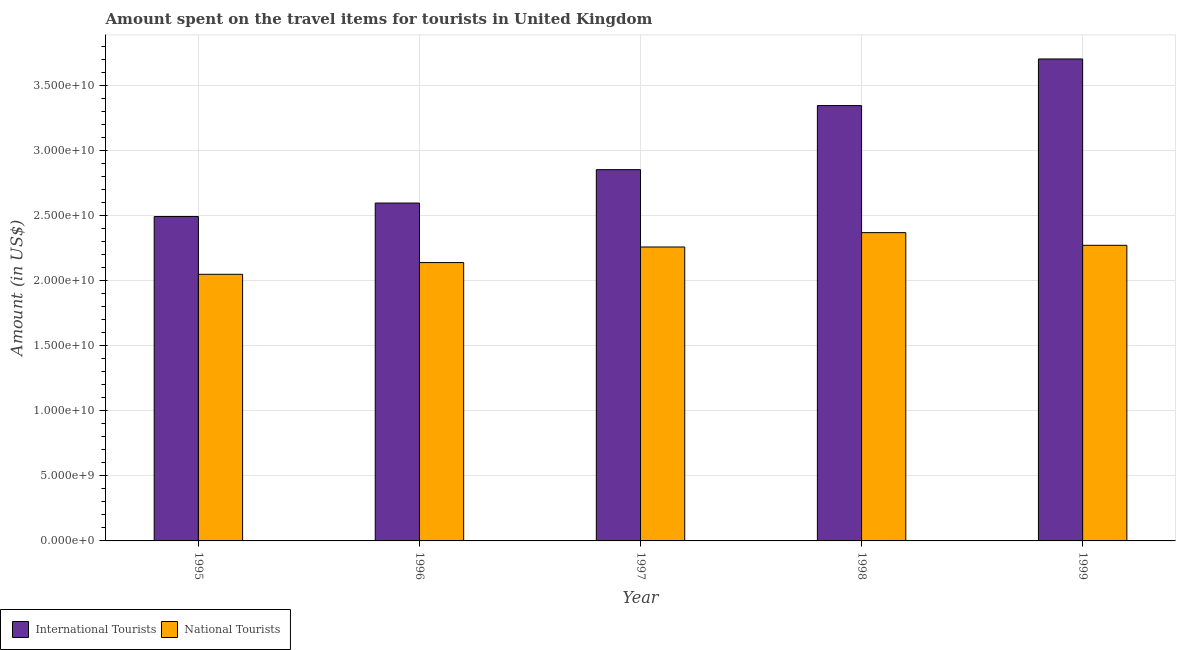How many different coloured bars are there?
Provide a succinct answer. 2. How many bars are there on the 3rd tick from the right?
Your answer should be very brief. 2. What is the label of the 5th group of bars from the left?
Your answer should be compact. 1999. In how many cases, is the number of bars for a given year not equal to the number of legend labels?
Your answer should be compact. 0. What is the amount spent on travel items of international tourists in 1999?
Your answer should be compact. 3.70e+1. Across all years, what is the maximum amount spent on travel items of international tourists?
Provide a succinct answer. 3.70e+1. Across all years, what is the minimum amount spent on travel items of national tourists?
Provide a succinct answer. 2.05e+1. In which year was the amount spent on travel items of national tourists minimum?
Provide a short and direct response. 1995. What is the total amount spent on travel items of national tourists in the graph?
Provide a succinct answer. 1.11e+11. What is the difference between the amount spent on travel items of international tourists in 1996 and that in 1998?
Give a very brief answer. -7.49e+09. What is the difference between the amount spent on travel items of international tourists in 1996 and the amount spent on travel items of national tourists in 1999?
Ensure brevity in your answer.  -1.11e+1. What is the average amount spent on travel items of international tourists per year?
Your answer should be very brief. 3.00e+1. What is the ratio of the amount spent on travel items of national tourists in 1995 to that in 1997?
Provide a succinct answer. 0.91. What is the difference between the highest and the second highest amount spent on travel items of national tourists?
Your response must be concise. 9.73e+08. What is the difference between the highest and the lowest amount spent on travel items of national tourists?
Provide a succinct answer. 3.20e+09. What does the 2nd bar from the left in 1995 represents?
Your response must be concise. National Tourists. What does the 1st bar from the right in 1996 represents?
Offer a terse response. National Tourists. How many years are there in the graph?
Provide a succinct answer. 5. Does the graph contain grids?
Your answer should be compact. Yes. How many legend labels are there?
Offer a very short reply. 2. What is the title of the graph?
Give a very brief answer. Amount spent on the travel items for tourists in United Kingdom. What is the label or title of the Y-axis?
Your response must be concise. Amount (in US$). What is the Amount (in US$) of International Tourists in 1995?
Make the answer very short. 2.49e+1. What is the Amount (in US$) of National Tourists in 1995?
Your answer should be very brief. 2.05e+1. What is the Amount (in US$) in International Tourists in 1996?
Make the answer very short. 2.60e+1. What is the Amount (in US$) in National Tourists in 1996?
Ensure brevity in your answer.  2.14e+1. What is the Amount (in US$) in International Tourists in 1997?
Your answer should be compact. 2.85e+1. What is the Amount (in US$) in National Tourists in 1997?
Offer a terse response. 2.26e+1. What is the Amount (in US$) in International Tourists in 1998?
Your answer should be very brief. 3.35e+1. What is the Amount (in US$) of National Tourists in 1998?
Provide a short and direct response. 2.37e+1. What is the Amount (in US$) in International Tourists in 1999?
Ensure brevity in your answer.  3.70e+1. What is the Amount (in US$) of National Tourists in 1999?
Provide a succinct answer. 2.27e+1. Across all years, what is the maximum Amount (in US$) in International Tourists?
Your response must be concise. 3.70e+1. Across all years, what is the maximum Amount (in US$) in National Tourists?
Keep it short and to the point. 2.37e+1. Across all years, what is the minimum Amount (in US$) in International Tourists?
Provide a short and direct response. 2.49e+1. Across all years, what is the minimum Amount (in US$) of National Tourists?
Offer a terse response. 2.05e+1. What is the total Amount (in US$) in International Tourists in the graph?
Your answer should be very brief. 1.50e+11. What is the total Amount (in US$) of National Tourists in the graph?
Keep it short and to the point. 1.11e+11. What is the difference between the Amount (in US$) of International Tourists in 1995 and that in 1996?
Your answer should be compact. -1.04e+09. What is the difference between the Amount (in US$) in National Tourists in 1995 and that in 1996?
Your answer should be compact. -9.02e+08. What is the difference between the Amount (in US$) in International Tourists in 1995 and that in 1997?
Keep it short and to the point. -3.60e+09. What is the difference between the Amount (in US$) of National Tourists in 1995 and that in 1997?
Your response must be concise. -2.10e+09. What is the difference between the Amount (in US$) of International Tourists in 1995 and that in 1998?
Provide a short and direct response. -8.53e+09. What is the difference between the Amount (in US$) of National Tourists in 1995 and that in 1998?
Make the answer very short. -3.20e+09. What is the difference between the Amount (in US$) of International Tourists in 1995 and that in 1999?
Your answer should be very brief. -1.21e+1. What is the difference between the Amount (in US$) in National Tourists in 1995 and that in 1999?
Provide a short and direct response. -2.23e+09. What is the difference between the Amount (in US$) in International Tourists in 1996 and that in 1997?
Provide a succinct answer. -2.57e+09. What is the difference between the Amount (in US$) in National Tourists in 1996 and that in 1997?
Your answer should be compact. -1.20e+09. What is the difference between the Amount (in US$) in International Tourists in 1996 and that in 1998?
Provide a succinct answer. -7.49e+09. What is the difference between the Amount (in US$) of National Tourists in 1996 and that in 1998?
Provide a succinct answer. -2.30e+09. What is the difference between the Amount (in US$) in International Tourists in 1996 and that in 1999?
Your response must be concise. -1.11e+1. What is the difference between the Amount (in US$) in National Tourists in 1996 and that in 1999?
Your answer should be compact. -1.33e+09. What is the difference between the Amount (in US$) of International Tourists in 1997 and that in 1998?
Make the answer very short. -4.92e+09. What is the difference between the Amount (in US$) of National Tourists in 1997 and that in 1998?
Your answer should be very brief. -1.10e+09. What is the difference between the Amount (in US$) of International Tourists in 1997 and that in 1999?
Your answer should be very brief. -8.50e+09. What is the difference between the Amount (in US$) of National Tourists in 1997 and that in 1999?
Offer a terse response. -1.30e+08. What is the difference between the Amount (in US$) in International Tourists in 1998 and that in 1999?
Give a very brief answer. -3.58e+09. What is the difference between the Amount (in US$) of National Tourists in 1998 and that in 1999?
Ensure brevity in your answer.  9.73e+08. What is the difference between the Amount (in US$) of International Tourists in 1995 and the Amount (in US$) of National Tourists in 1996?
Give a very brief answer. 3.54e+09. What is the difference between the Amount (in US$) of International Tourists in 1995 and the Amount (in US$) of National Tourists in 1997?
Your answer should be very brief. 2.34e+09. What is the difference between the Amount (in US$) in International Tourists in 1995 and the Amount (in US$) in National Tourists in 1998?
Your response must be concise. 1.24e+09. What is the difference between the Amount (in US$) of International Tourists in 1995 and the Amount (in US$) of National Tourists in 1999?
Provide a short and direct response. 2.21e+09. What is the difference between the Amount (in US$) in International Tourists in 1996 and the Amount (in US$) in National Tourists in 1997?
Your answer should be very brief. 3.38e+09. What is the difference between the Amount (in US$) of International Tourists in 1996 and the Amount (in US$) of National Tourists in 1998?
Make the answer very short. 2.27e+09. What is the difference between the Amount (in US$) in International Tourists in 1996 and the Amount (in US$) in National Tourists in 1999?
Your answer should be very brief. 3.25e+09. What is the difference between the Amount (in US$) of International Tourists in 1997 and the Amount (in US$) of National Tourists in 1998?
Your response must be concise. 4.84e+09. What is the difference between the Amount (in US$) of International Tourists in 1997 and the Amount (in US$) of National Tourists in 1999?
Your answer should be very brief. 5.81e+09. What is the difference between the Amount (in US$) of International Tourists in 1998 and the Amount (in US$) of National Tourists in 1999?
Your answer should be compact. 1.07e+1. What is the average Amount (in US$) in International Tourists per year?
Your response must be concise. 3.00e+1. What is the average Amount (in US$) in National Tourists per year?
Give a very brief answer. 2.22e+1. In the year 1995, what is the difference between the Amount (in US$) in International Tourists and Amount (in US$) in National Tourists?
Your answer should be very brief. 4.44e+09. In the year 1996, what is the difference between the Amount (in US$) in International Tourists and Amount (in US$) in National Tourists?
Your response must be concise. 4.57e+09. In the year 1997, what is the difference between the Amount (in US$) of International Tourists and Amount (in US$) of National Tourists?
Provide a succinct answer. 5.94e+09. In the year 1998, what is the difference between the Amount (in US$) in International Tourists and Amount (in US$) in National Tourists?
Provide a succinct answer. 9.76e+09. In the year 1999, what is the difference between the Amount (in US$) in International Tourists and Amount (in US$) in National Tourists?
Ensure brevity in your answer.  1.43e+1. What is the ratio of the Amount (in US$) of International Tourists in 1995 to that in 1996?
Your answer should be compact. 0.96. What is the ratio of the Amount (in US$) in National Tourists in 1995 to that in 1996?
Your response must be concise. 0.96. What is the ratio of the Amount (in US$) in International Tourists in 1995 to that in 1997?
Provide a succinct answer. 0.87. What is the ratio of the Amount (in US$) in National Tourists in 1995 to that in 1997?
Provide a succinct answer. 0.91. What is the ratio of the Amount (in US$) of International Tourists in 1995 to that in 1998?
Your answer should be very brief. 0.75. What is the ratio of the Amount (in US$) of National Tourists in 1995 to that in 1998?
Give a very brief answer. 0.86. What is the ratio of the Amount (in US$) in International Tourists in 1995 to that in 1999?
Provide a succinct answer. 0.67. What is the ratio of the Amount (in US$) of National Tourists in 1995 to that in 1999?
Keep it short and to the point. 0.9. What is the ratio of the Amount (in US$) of International Tourists in 1996 to that in 1997?
Your answer should be very brief. 0.91. What is the ratio of the Amount (in US$) in National Tourists in 1996 to that in 1997?
Offer a very short reply. 0.95. What is the ratio of the Amount (in US$) in International Tourists in 1996 to that in 1998?
Provide a short and direct response. 0.78. What is the ratio of the Amount (in US$) in National Tourists in 1996 to that in 1998?
Give a very brief answer. 0.9. What is the ratio of the Amount (in US$) in International Tourists in 1996 to that in 1999?
Your response must be concise. 0.7. What is the ratio of the Amount (in US$) in National Tourists in 1996 to that in 1999?
Your response must be concise. 0.94. What is the ratio of the Amount (in US$) of International Tourists in 1997 to that in 1998?
Your response must be concise. 0.85. What is the ratio of the Amount (in US$) of National Tourists in 1997 to that in 1998?
Give a very brief answer. 0.95. What is the ratio of the Amount (in US$) of International Tourists in 1997 to that in 1999?
Keep it short and to the point. 0.77. What is the ratio of the Amount (in US$) of National Tourists in 1997 to that in 1999?
Keep it short and to the point. 0.99. What is the ratio of the Amount (in US$) of International Tourists in 1998 to that in 1999?
Your answer should be compact. 0.9. What is the ratio of the Amount (in US$) of National Tourists in 1998 to that in 1999?
Keep it short and to the point. 1.04. What is the difference between the highest and the second highest Amount (in US$) in International Tourists?
Ensure brevity in your answer.  3.58e+09. What is the difference between the highest and the second highest Amount (in US$) of National Tourists?
Provide a succinct answer. 9.73e+08. What is the difference between the highest and the lowest Amount (in US$) of International Tourists?
Your answer should be compact. 1.21e+1. What is the difference between the highest and the lowest Amount (in US$) of National Tourists?
Give a very brief answer. 3.20e+09. 